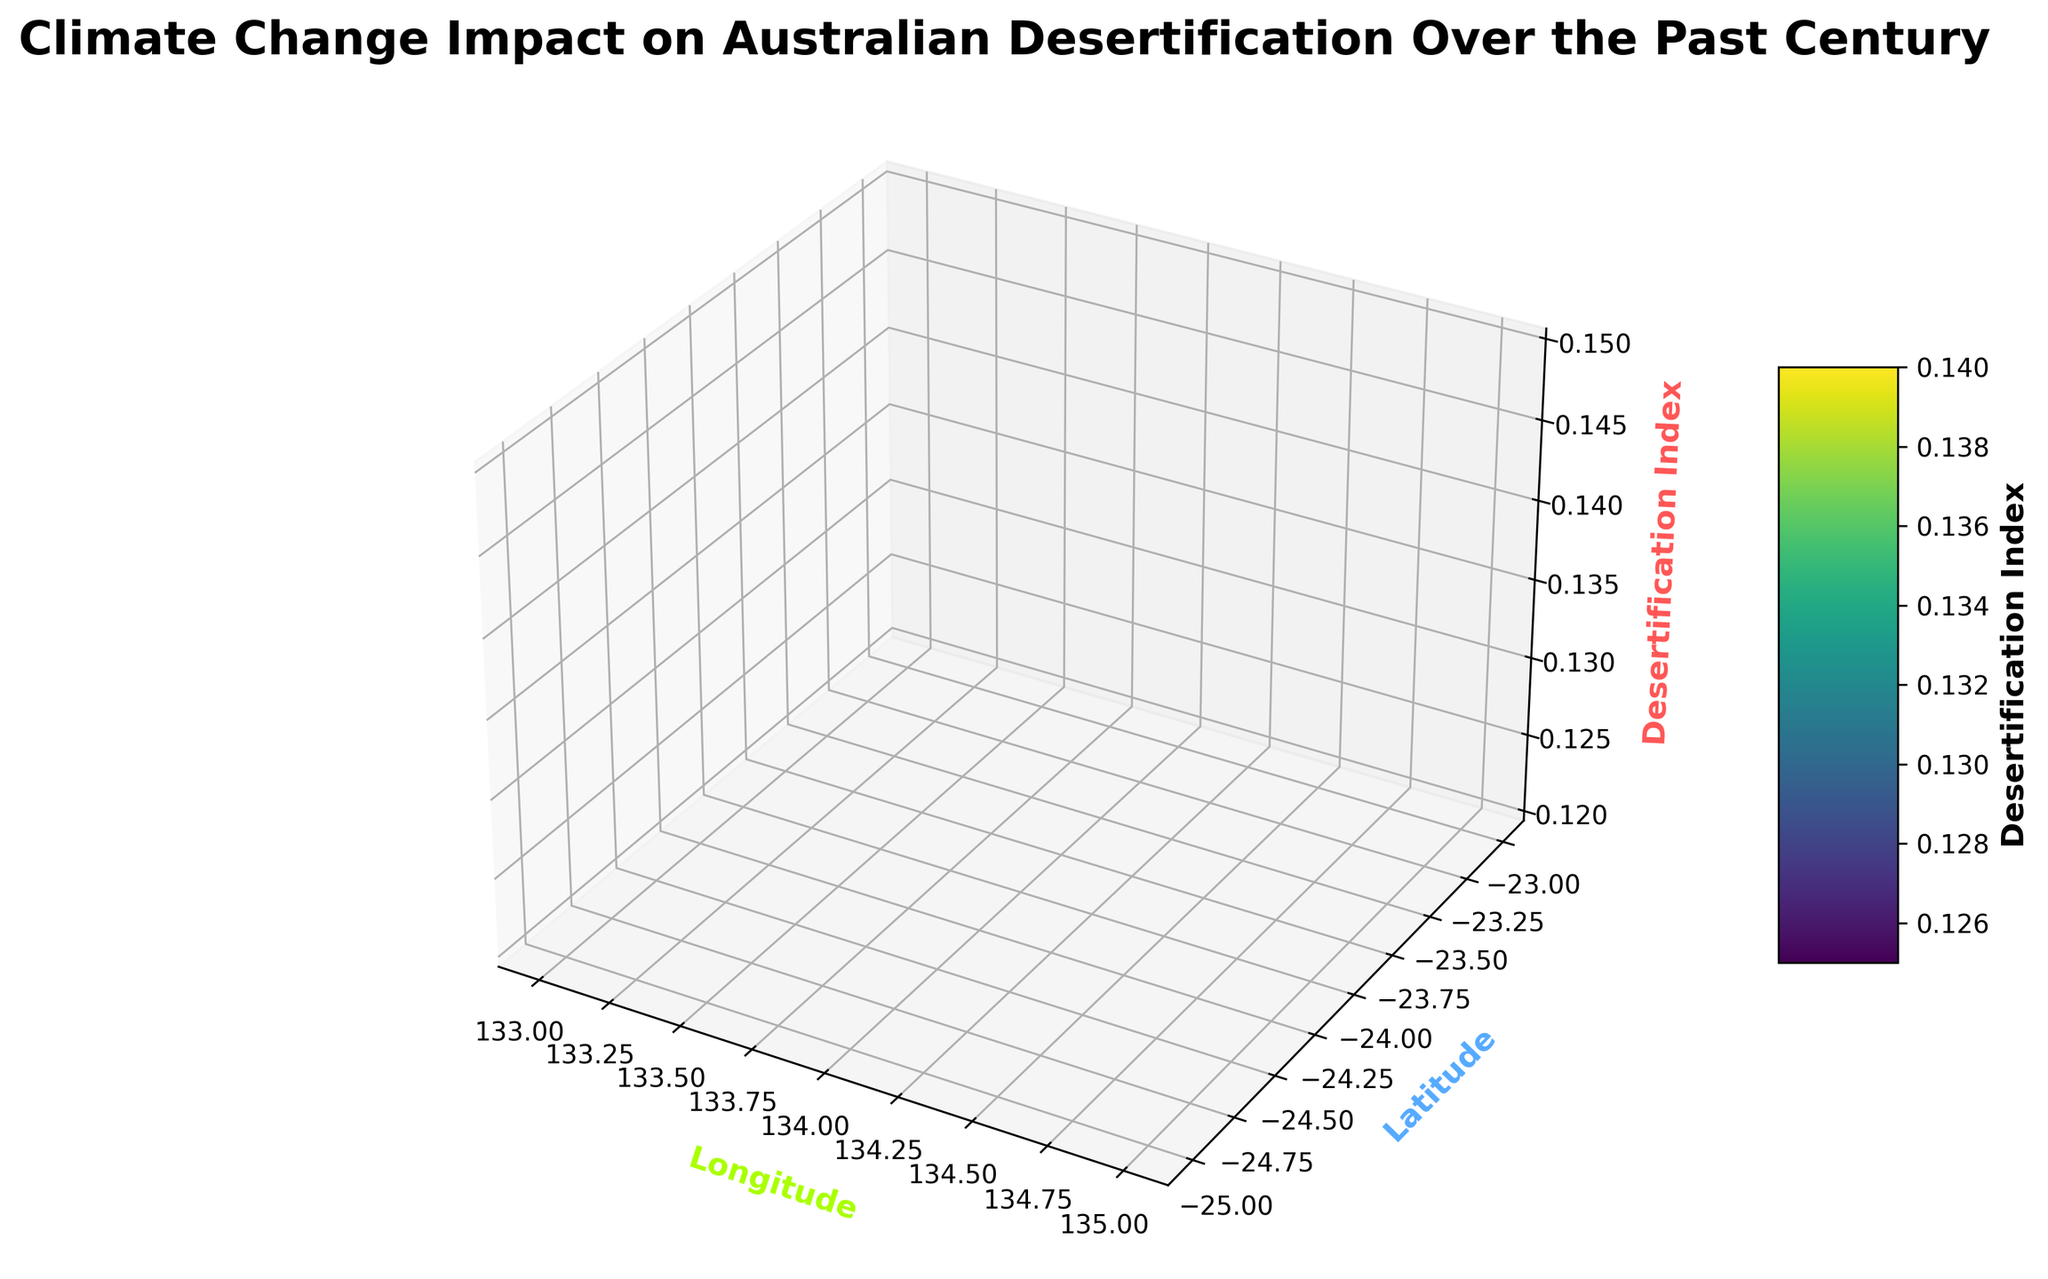What is the general trend in the desertification index over time? Observing the z-axis which represents the desertification index, we can see a rising trend, indicating increasing desertification over time. This is evidenced by the heights of the surface plot increasing from the 1920s to the 2020s.
Answer: Increasing How does the desertification index at latitude -23.0 and longitude 133.0 in 2020 compare to that in 1920? By looking at the height of the surface plot for the coordinate (-23.0, 133.0) in both 2020 and 1920, we see that the height is much greater in 2020, indicating a higher desertification index.
Answer: Higher in 2020 Between latitude -24.0 and latitude -25.0, which one shows a higher desertification index in the 2010s? By examining the heights of the surface plot along the defined latitudes for 2010, we notice that latitude -24.0 has a slightly higher elevation compared to -25.0, indicating a higher desertification index at -24.0 in the 2010s.
Answer: -24.0 What is the average desertification index at latitude -23.0 for the years 1920 and 1930? Turning to the points that correspond to latitude -23.0, the desertification indices for 1920 and 1930 are 0.15 and 0.18 respectively. The average is calculated as (0.15 + 0.18) / 2 = 0.165.
Answer: 0.165 In which decade is the increase in the desertification index from the previous decade the greatest? By comparing the differences in desertification indices from one decade to the next for a specific location (e.g., -23.0 latitude and 133.0 longitude), the largest increase occurs between the 1930s and 1940s, rising from 0.18 to 0.20.
Answer: 1940s Is there any significant spatial variation in desertification indices across different longitudes at the same latitude? Observing the surface plot at fixed latitudes but spanning different longitudes (133.0 to 135.0), the surface appears relatively uniform, suggesting minor spatial variation across longitudes at the same latitude.
Answer: Minor spatial variation By how much did the desertification index at latitude -24.0, longitude 134.0 increase from 1960 to 1980? Desertification indices for 1960 and 1980 at the specified coordinates are 0.23 and 0.28, respectively. The increase is calculated as 0.28 - 0.23 = 0.05.
Answer: 0.05 What color represents a high desertification index in the plot? The color bar indicates that higher desertification indices are represented by colors transitioning towards yellow in the viridis colormap used.
Answer: Yellow 